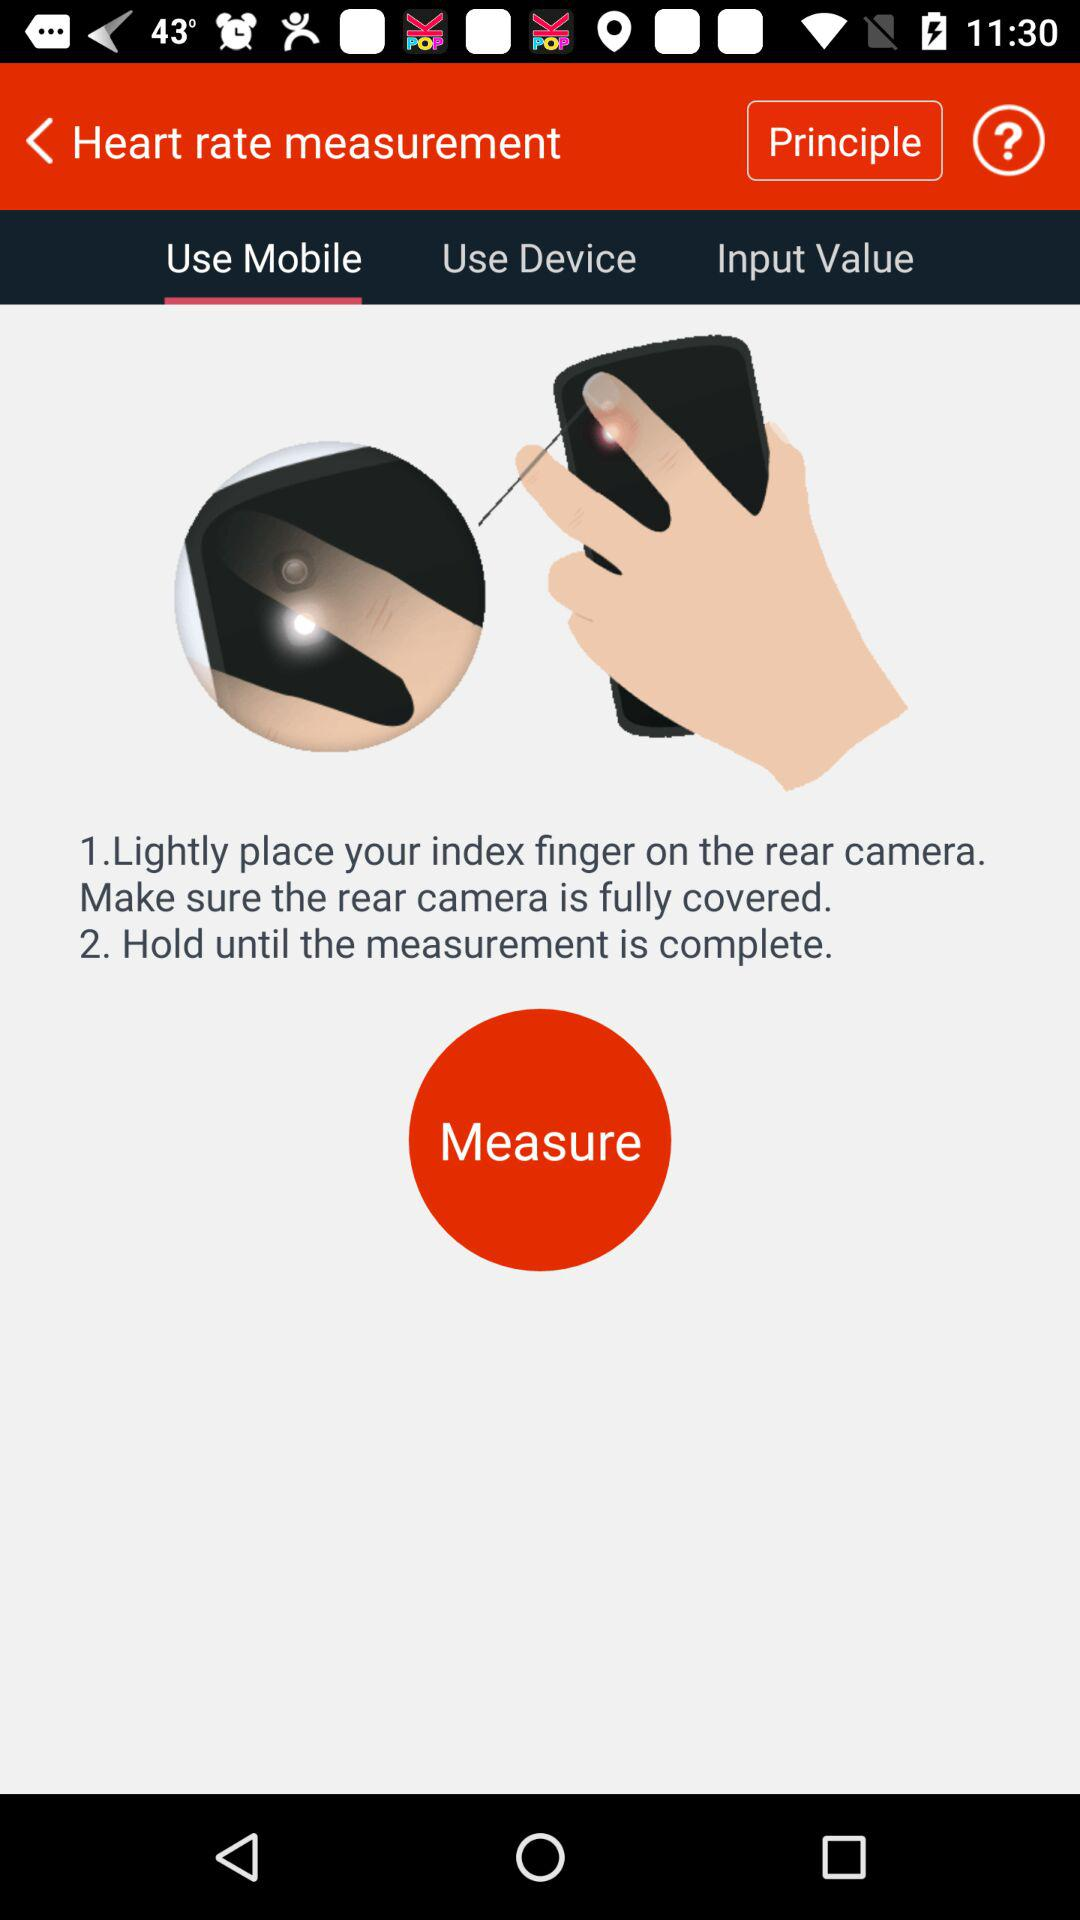How many steps are there in the instructions?
Answer the question using a single word or phrase. 2 